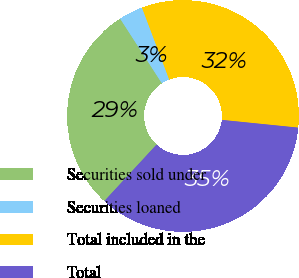Convert chart. <chart><loc_0><loc_0><loc_500><loc_500><pie_chart><fcel>Securities sold under<fcel>Securities loaned<fcel>Total included in the<fcel>Total<nl><fcel>29.0%<fcel>3.37%<fcel>32.37%<fcel>35.27%<nl></chart> 